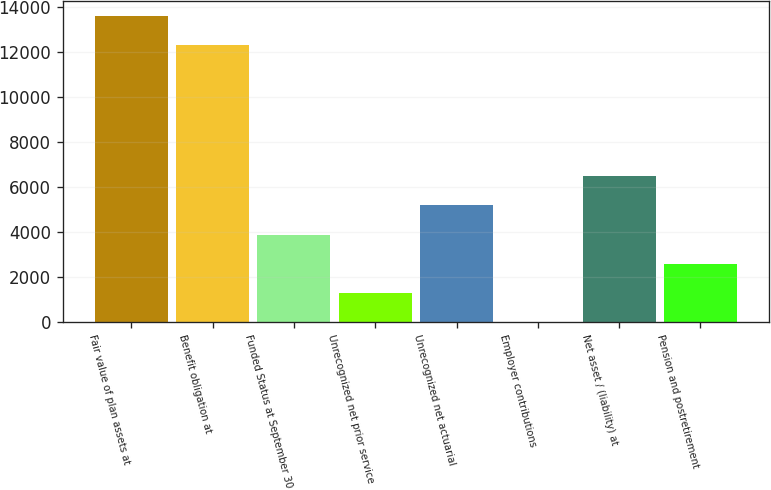Convert chart. <chart><loc_0><loc_0><loc_500><loc_500><bar_chart><fcel>Fair value of plan assets at<fcel>Benefit obligation at<fcel>Funded Status at September 30<fcel>Unrecognized net prior service<fcel>Unrecognized net actuarial<fcel>Employer contributions<fcel>Net asset / (liability) at<fcel>Pension and postretirement<nl><fcel>13593.1<fcel>12299<fcel>3884.3<fcel>1296.1<fcel>5178.4<fcel>2<fcel>6472.5<fcel>2590.2<nl></chart> 